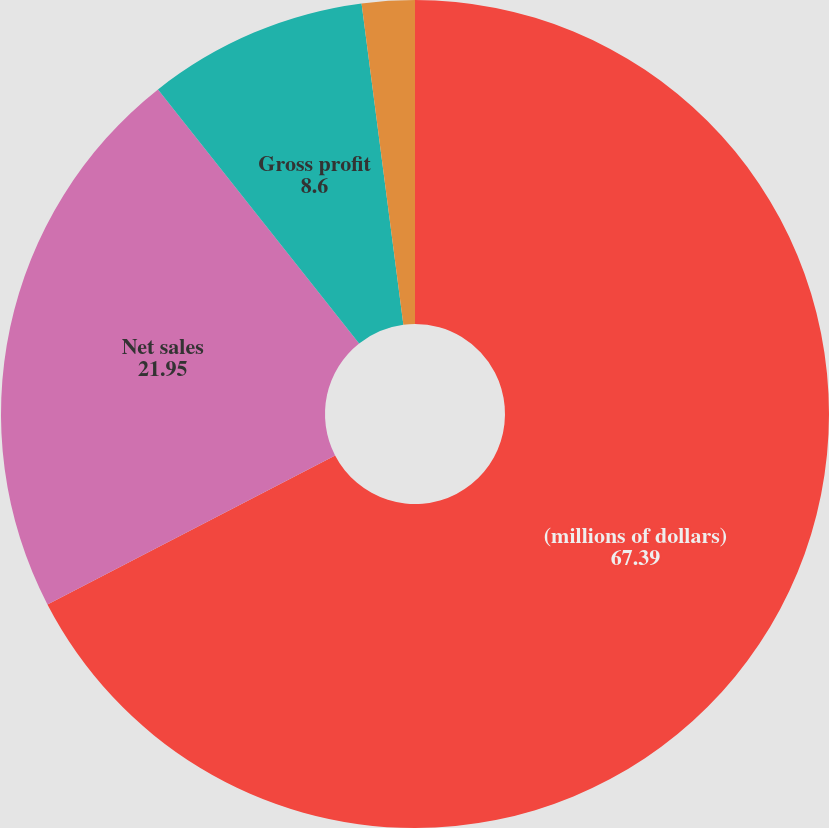Convert chart. <chart><loc_0><loc_0><loc_500><loc_500><pie_chart><fcel>(millions of dollars)<fcel>Net sales<fcel>Gross profit<fcel>Net earnings<nl><fcel>67.39%<fcel>21.95%<fcel>8.6%<fcel>2.06%<nl></chart> 